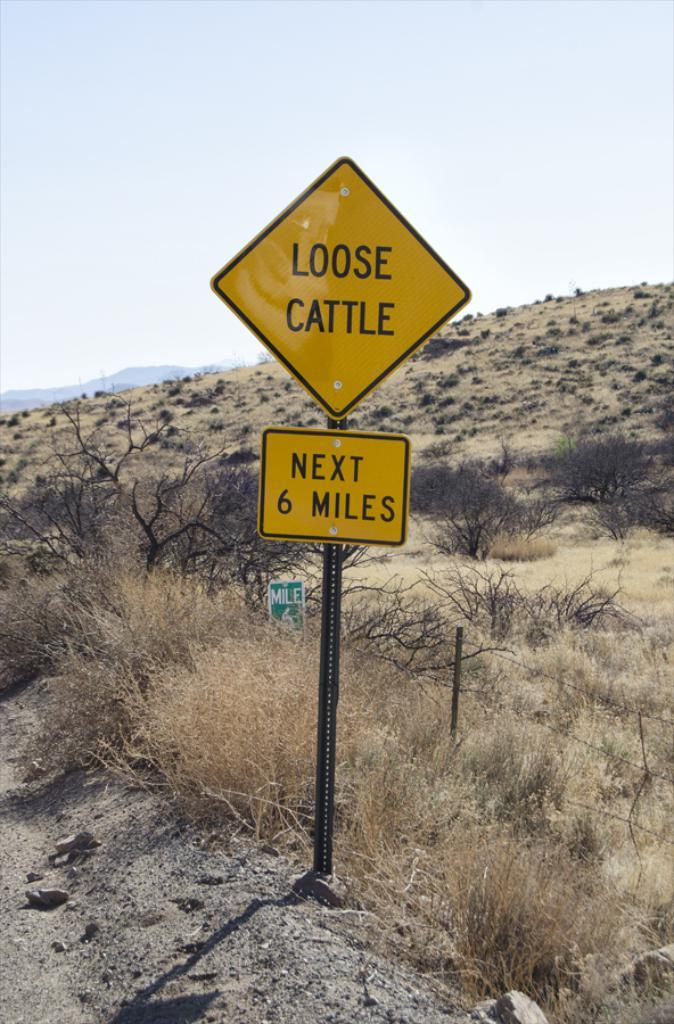Provide a one-sentence caption for the provided image. Diamond shaped yellow sign for any loose cattle. 